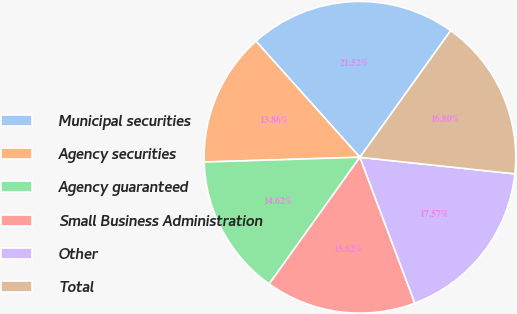Convert chart to OTSL. <chart><loc_0><loc_0><loc_500><loc_500><pie_chart><fcel>Municipal securities<fcel>Agency securities<fcel>Agency guaranteed<fcel>Small Business Administration<fcel>Other<fcel>Total<nl><fcel>21.52%<fcel>13.86%<fcel>14.62%<fcel>15.62%<fcel>17.57%<fcel>16.8%<nl></chart> 